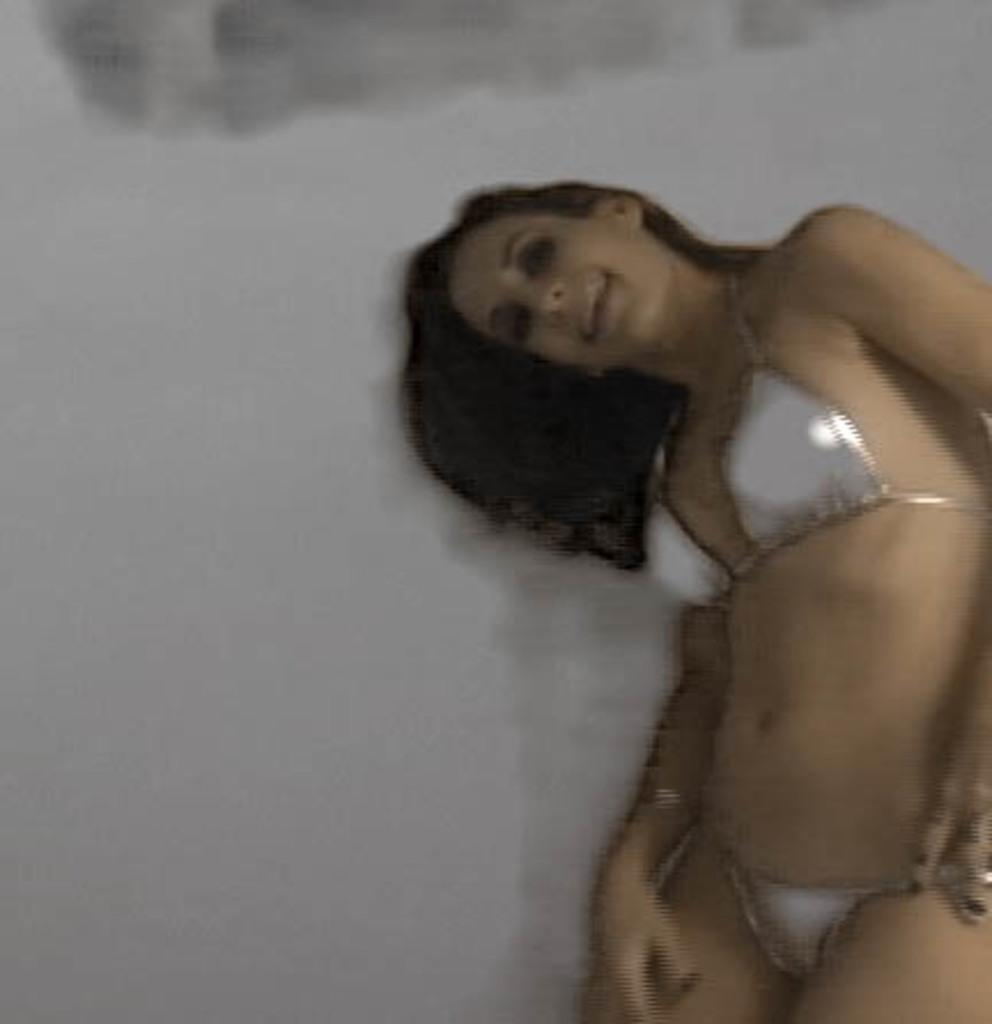What is the main subject of the image? There is a person in the image. Where is the person located in relation to the wall? The person is in front of a wall. What type of leaf is growing on the person's head in the image? There is no leaf present on the person's head in the image. What color is the patch on the wall in the image? The facts do not mention any patches on the wall, so we cannot determine the color of a patch. 